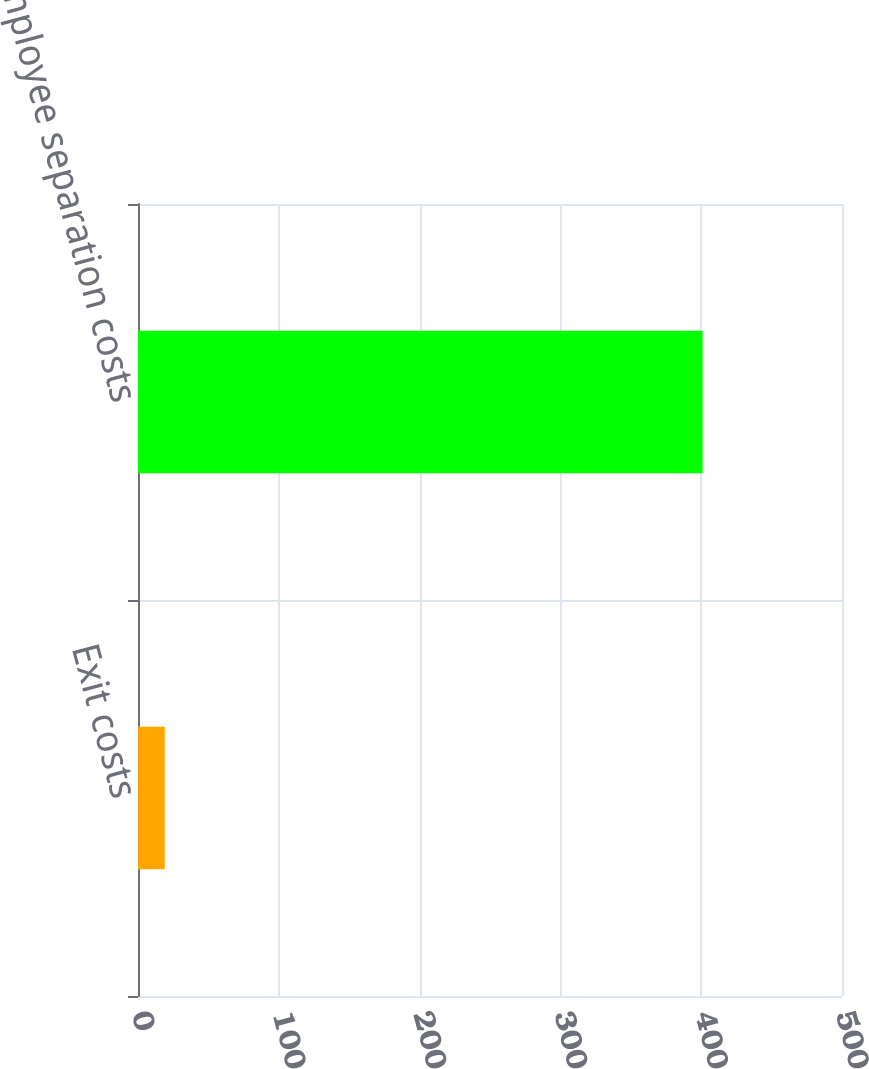Convert chart to OTSL. <chart><loc_0><loc_0><loc_500><loc_500><bar_chart><fcel>Exit costs<fcel>Employee separation costs<nl><fcel>19<fcel>401<nl></chart> 